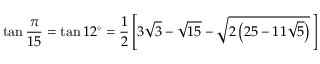Convert formula to latex. <formula><loc_0><loc_0><loc_500><loc_500>\tan { \frac { \pi } { 1 5 } } = \tan 1 2 ^ { \circ } = { \frac { 1 } { 2 } } \left [ 3 { \sqrt { 3 } } - { \sqrt { 1 5 } } - { \sqrt { 2 \left ( 2 5 - 1 1 { \sqrt { 5 } } \right ) } } \, \right ]</formula> 